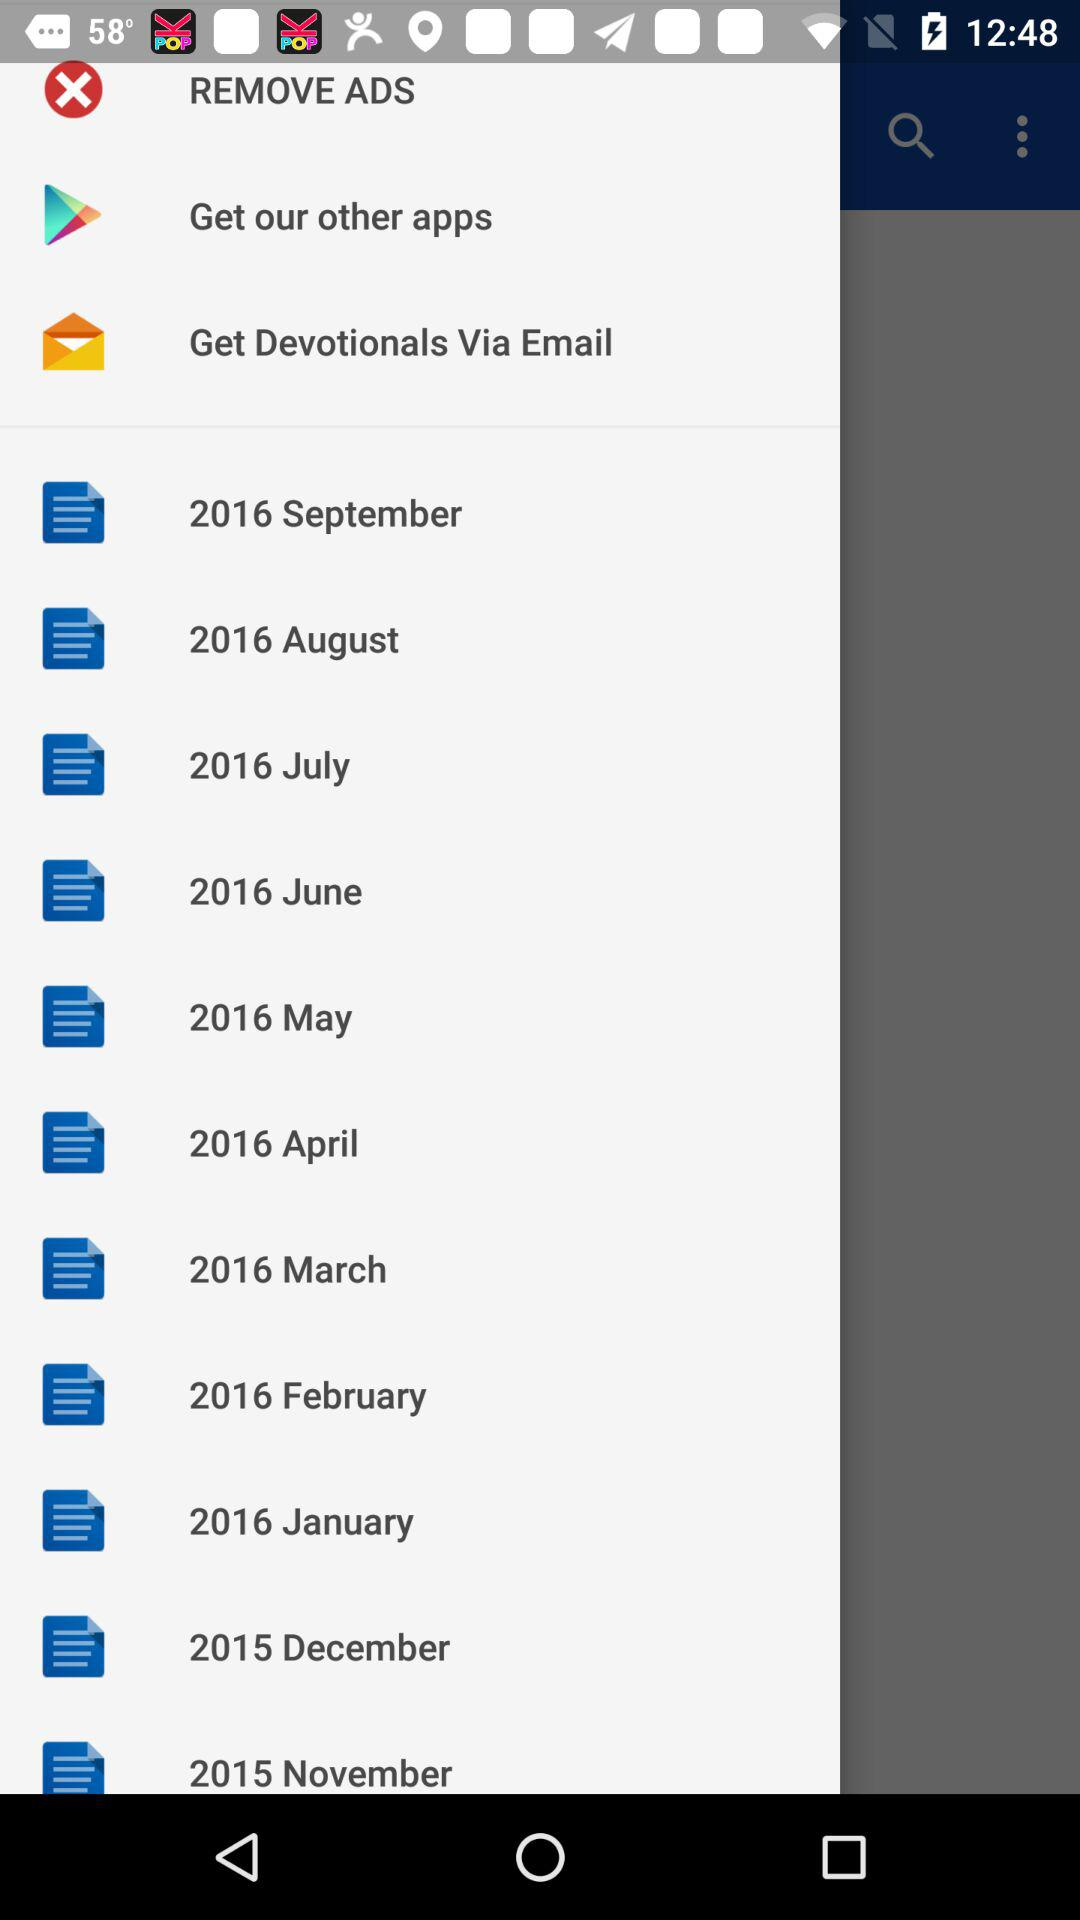What are the available items? The available items are "REMOVE ADS", "Get our other apps", "Get Devotionals Via Email", "2016 September", "2016 August", "2016 July", "2016 June", "2016 May", "2016 April", "2016 March", "2016 February", "2016 January", "2015 December" and "2015 November". 